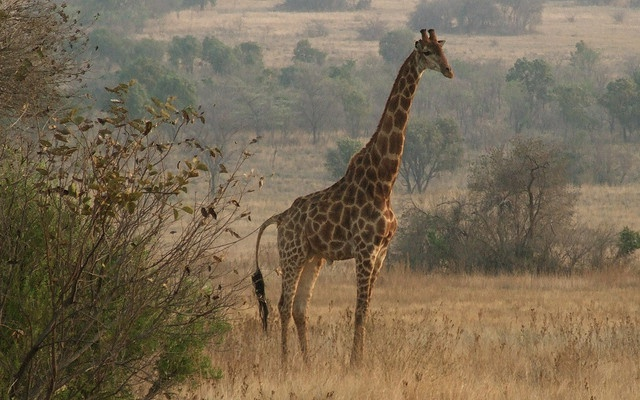Describe the objects in this image and their specific colors. I can see a giraffe in gray, black, and maroon tones in this image. 